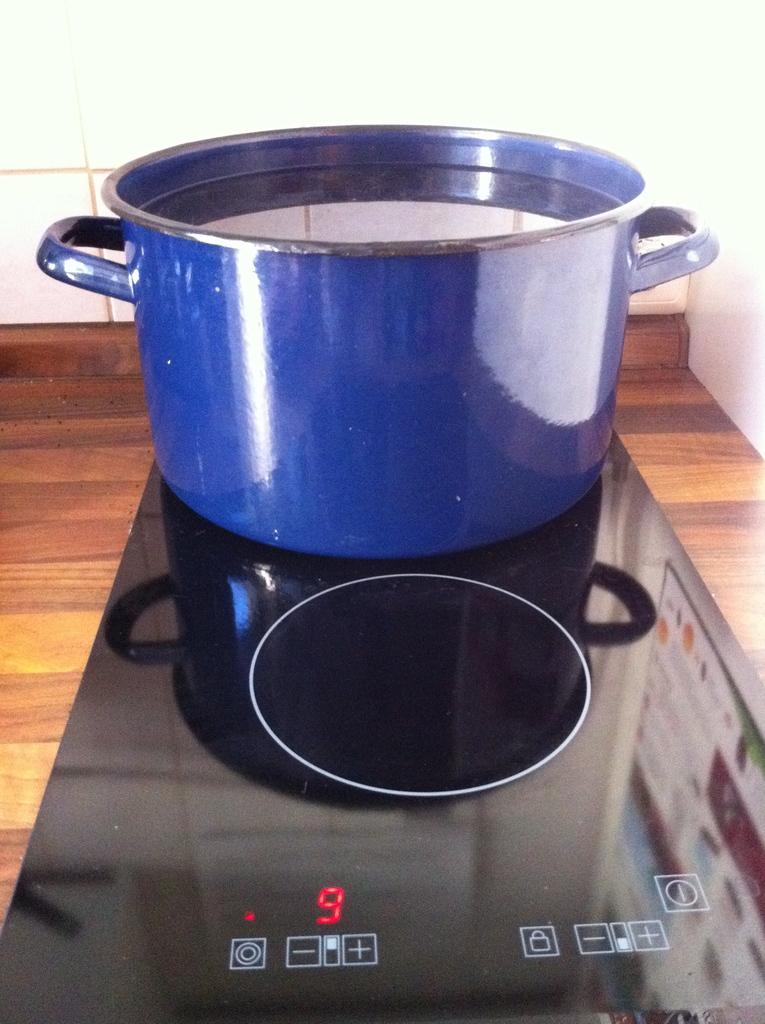What number is the pot set to?
Your answer should be compact. 9. What number is shown in red on the stove?
Provide a succinct answer. 9. 